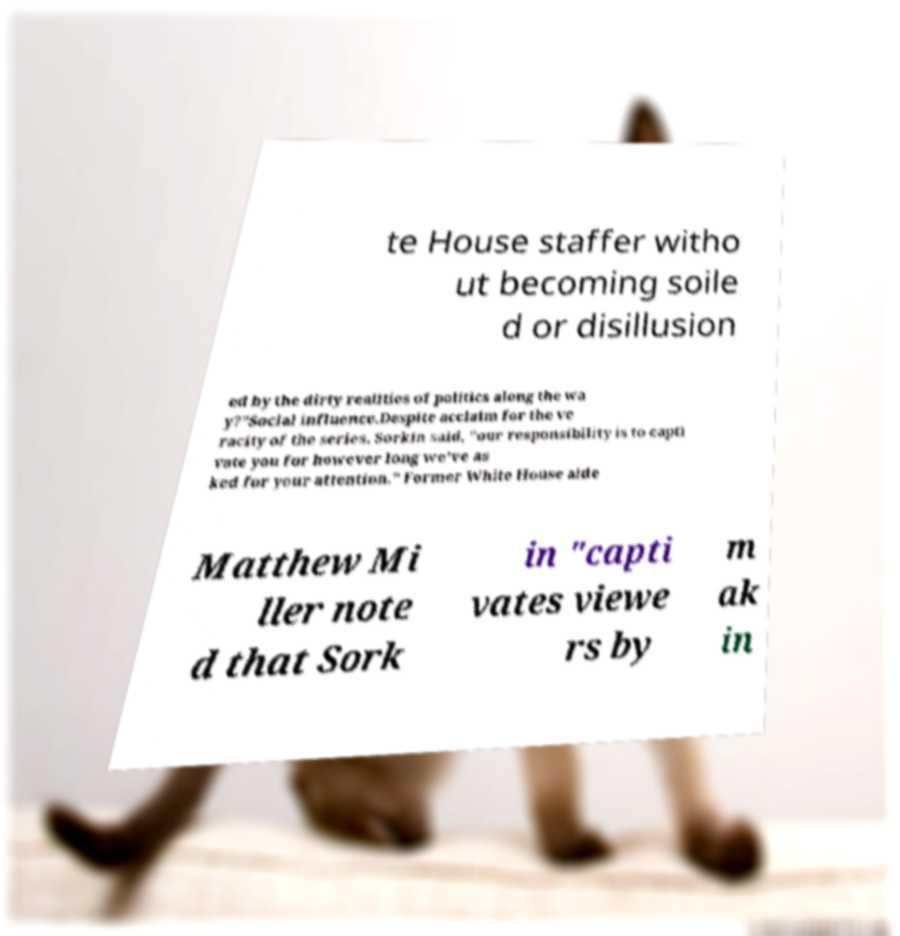Can you read and provide the text displayed in the image?This photo seems to have some interesting text. Can you extract and type it out for me? te House staffer witho ut becoming soile d or disillusion ed by the dirty realities of politics along the wa y?"Social influence.Despite acclaim for the ve racity of the series, Sorkin said, "our responsibility is to capti vate you for however long we've as ked for your attention." Former White House aide Matthew Mi ller note d that Sork in "capti vates viewe rs by m ak in 